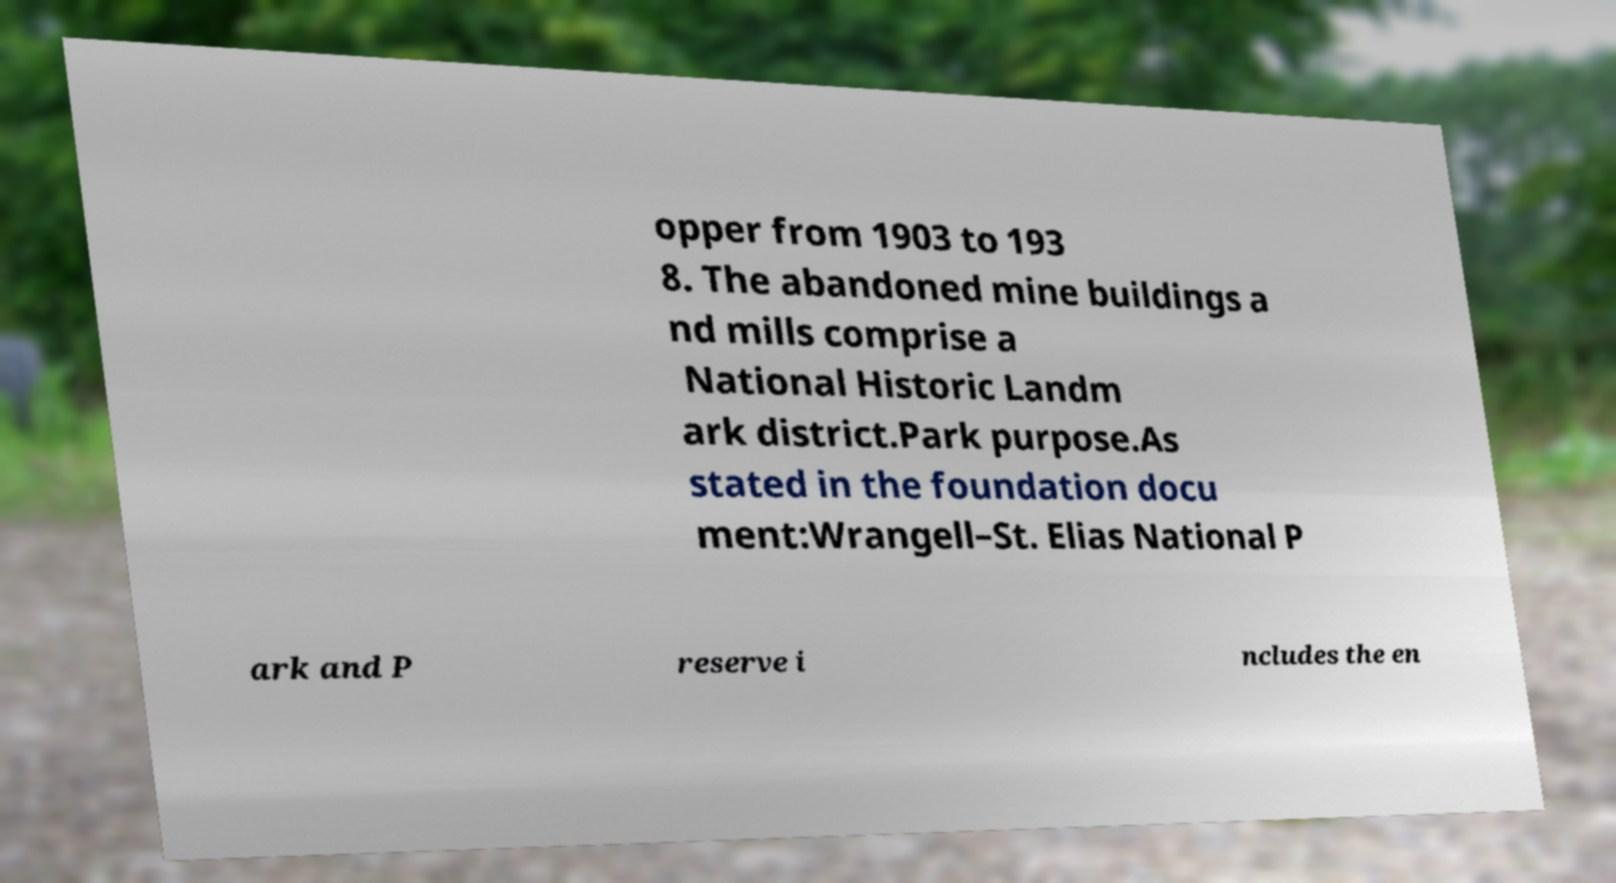I need the written content from this picture converted into text. Can you do that? opper from 1903 to 193 8. The abandoned mine buildings a nd mills comprise a National Historic Landm ark district.Park purpose.As stated in the foundation docu ment:Wrangell–St. Elias National P ark and P reserve i ncludes the en 